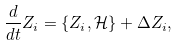Convert formula to latex. <formula><loc_0><loc_0><loc_500><loc_500>\frac { d } { d t } Z _ { i } = \{ Z _ { i } , \mathcal { H } \} + \Delta Z _ { i } ,</formula> 